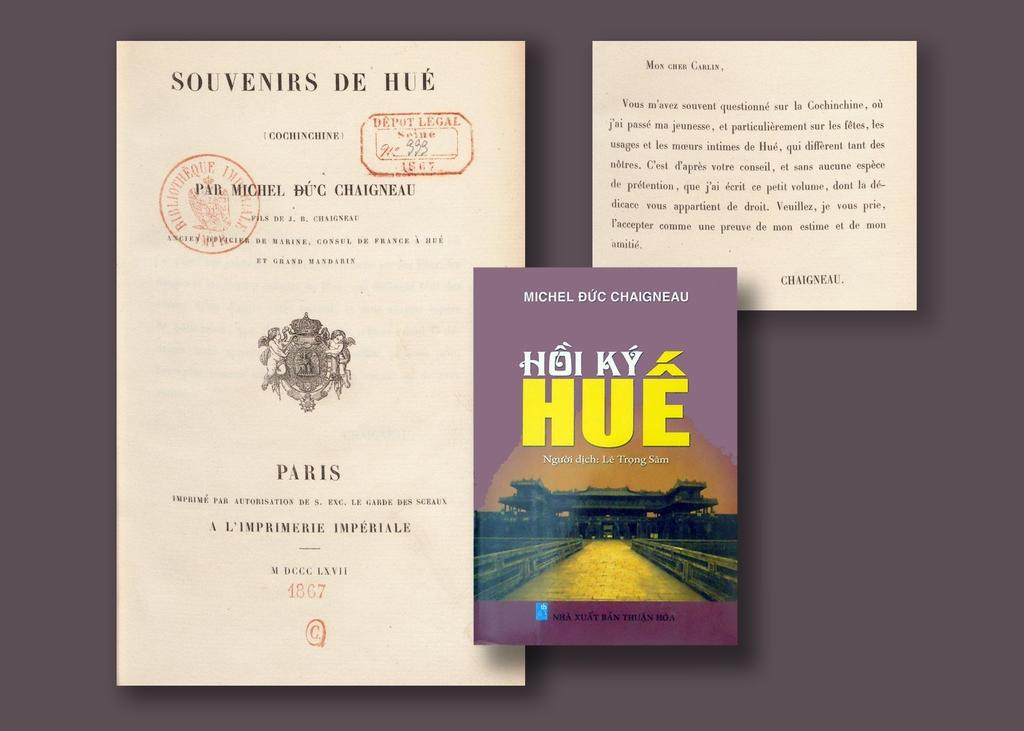<image>
Relay a brief, clear account of the picture shown. a few papers and a book on top of them by michel buc chaigneau 